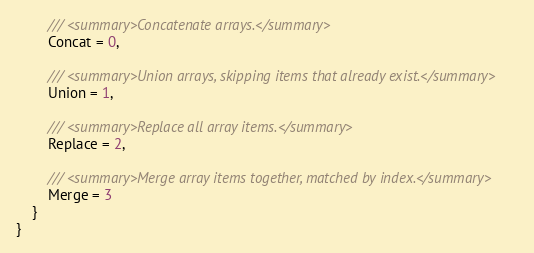Convert code to text. <code><loc_0><loc_0><loc_500><loc_500><_C#_>        /// <summary>Concatenate arrays.</summary>
        Concat = 0,

        /// <summary>Union arrays, skipping items that already exist.</summary>
        Union = 1,

        /// <summary>Replace all array items.</summary>
        Replace = 2,

        /// <summary>Merge array items together, matched by index.</summary>
        Merge = 3
    }
}</code> 